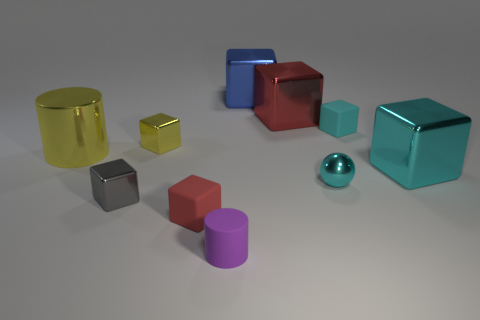Is the color of the metallic cylinder the same as the tiny metal thing that is behind the small cyan shiny thing?
Offer a terse response. Yes. There is a tiny block that is the same color as the small sphere; what is it made of?
Ensure brevity in your answer.  Rubber. How many objects are either tiny cyan matte things to the left of the cyan shiny block or big objects that are in front of the tiny cyan matte thing?
Give a very brief answer. 3. Is the size of the cyan ball that is on the right side of the rubber cylinder the same as the red block that is right of the big blue shiny block?
Ensure brevity in your answer.  No. What color is the tiny object that is the same shape as the big yellow metallic object?
Your answer should be compact. Purple. Is there anything else that has the same shape as the large cyan thing?
Your answer should be very brief. Yes. Are there more shiny blocks that are on the right side of the large red cube than tiny yellow shiny things that are in front of the tiny metallic sphere?
Keep it short and to the point. Yes. There is a red block to the left of the red block that is to the right of the small rubber block in front of the small gray block; what is its size?
Keep it short and to the point. Small. Are the tiny purple object and the red object in front of the large yellow metallic object made of the same material?
Your answer should be very brief. Yes. Does the big blue metallic thing have the same shape as the cyan matte object?
Your response must be concise. Yes. 